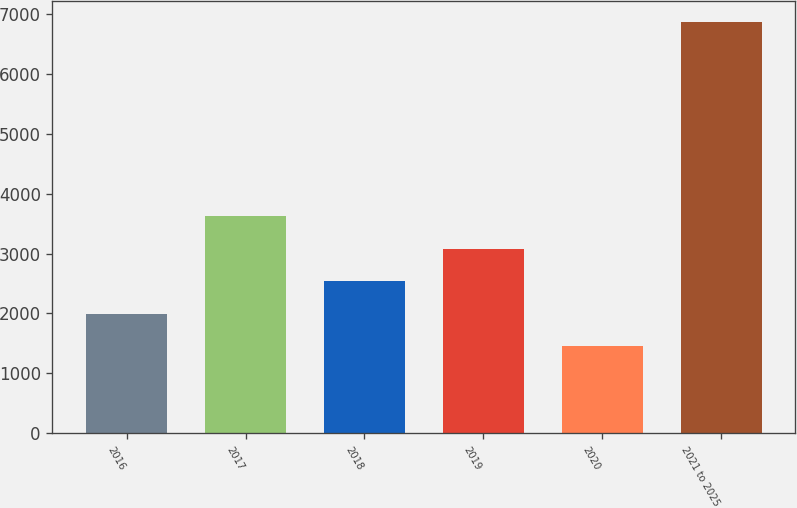Convert chart to OTSL. <chart><loc_0><loc_0><loc_500><loc_500><bar_chart><fcel>2016<fcel>2017<fcel>2018<fcel>2019<fcel>2020<fcel>2021 to 2025<nl><fcel>1991.7<fcel>3619.8<fcel>2534.4<fcel>3077.1<fcel>1449<fcel>6876<nl></chart> 